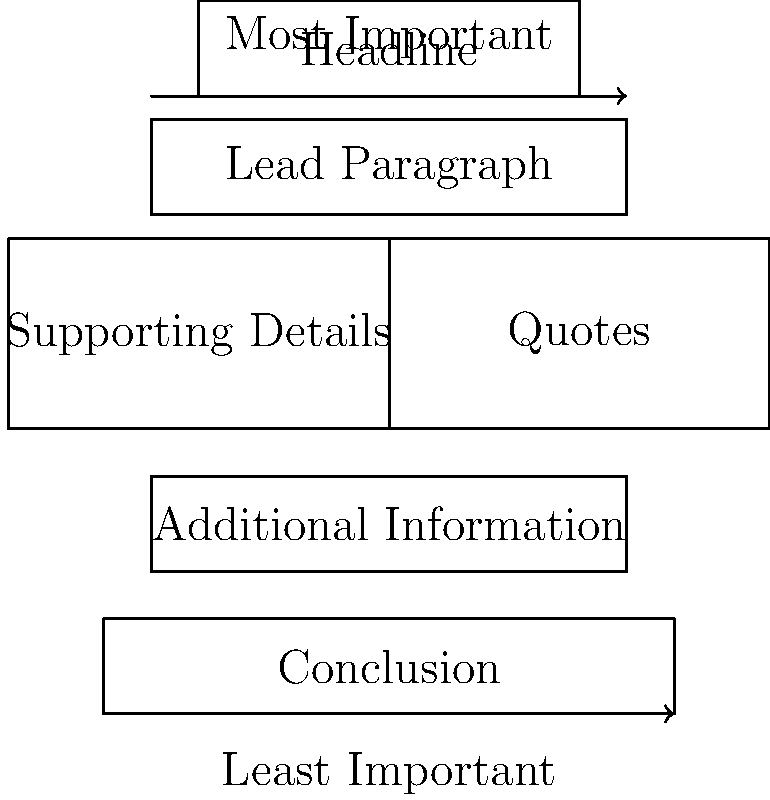Based on the infographic of a typical news article structure, which element should contain the most crucial information and be written to grab the reader's attention immediately? To answer this question, let's analyze the structure of the news article as shown in the infographic:

1. The infographic displays a top-to-bottom hierarchy of elements in a typical news article.

2. At the very top, we see the "Headline" box.

3. Directly below the headline is the "Lead Paragraph" box.

4. The arrow on the left side indicates that the information goes from "Most Important" at the top to "Least Important" at the bottom.

5. In journalistic writing, the most crucial information is typically presented at the beginning of the article to immediately capture the reader's attention.

6. While the headline is important for attracting readers, it's usually brief and doesn't contain all the key information.

7. The lead paragraph, also known as the lede, is designed to provide the most essential information of the story, answering the key questions of who, what, when, where, why, and how.

8. The lead paragraph is meant to give readers a quick summary of the most important aspects of the story, allowing them to decide if they want to continue reading.

Therefore, based on the structure and journalistic principles, the lead paragraph should contain the most crucial information and be written to grab the reader's attention immediately.
Answer: Lead Paragraph 